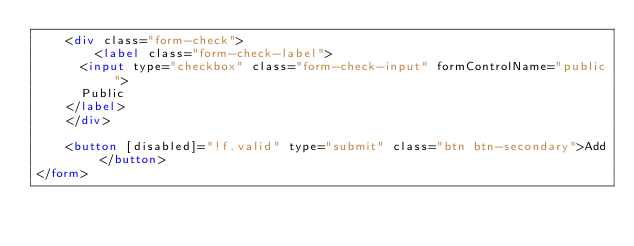<code> <loc_0><loc_0><loc_500><loc_500><_HTML_>    <div class="form-check">
        <label class="form-check-label">
      <input type="checkbox" class="form-check-input" formControlName="public">
      Public
    </label>
    </div>

    <button [disabled]="!f.valid" type="submit" class="btn btn-secondary">Add</button>
</form></code> 